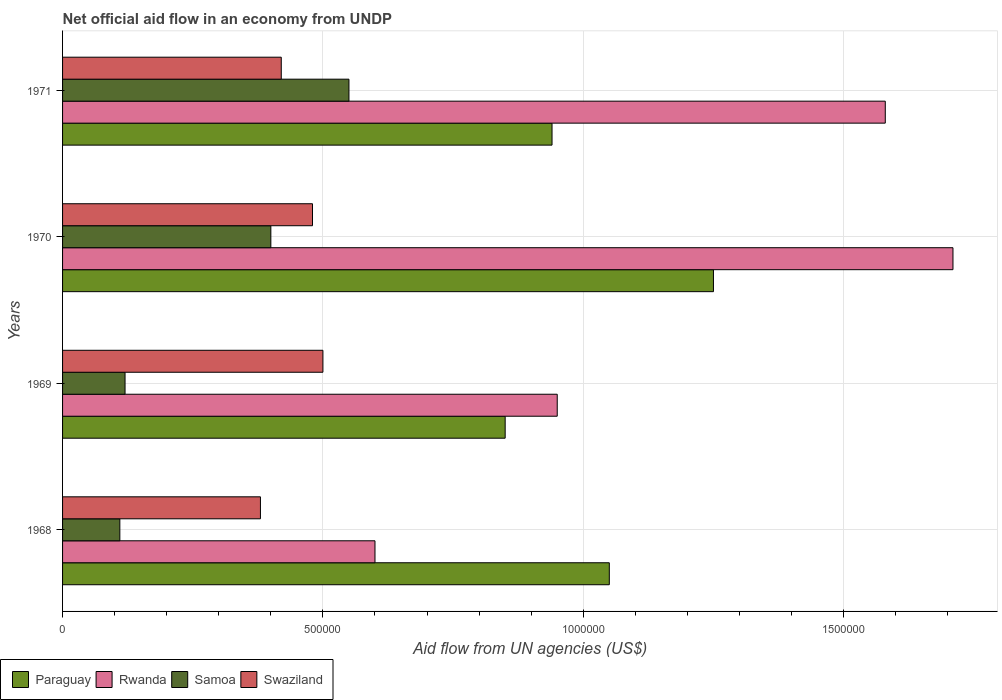Are the number of bars per tick equal to the number of legend labels?
Give a very brief answer. Yes. Are the number of bars on each tick of the Y-axis equal?
Offer a very short reply. Yes. How many bars are there on the 2nd tick from the bottom?
Your answer should be compact. 4. What is the label of the 3rd group of bars from the top?
Provide a short and direct response. 1969. What is the net official aid flow in Paraguay in 1969?
Ensure brevity in your answer.  8.50e+05. Across all years, what is the maximum net official aid flow in Paraguay?
Your answer should be compact. 1.25e+06. Across all years, what is the minimum net official aid flow in Paraguay?
Your answer should be compact. 8.50e+05. In which year was the net official aid flow in Paraguay maximum?
Make the answer very short. 1970. In which year was the net official aid flow in Swaziland minimum?
Provide a succinct answer. 1968. What is the total net official aid flow in Swaziland in the graph?
Your response must be concise. 1.78e+06. What is the difference between the net official aid flow in Samoa in 1969 and that in 1971?
Keep it short and to the point. -4.30e+05. What is the difference between the net official aid flow in Rwanda in 1971 and the net official aid flow in Samoa in 1969?
Give a very brief answer. 1.46e+06. What is the average net official aid flow in Swaziland per year?
Make the answer very short. 4.45e+05. In the year 1971, what is the difference between the net official aid flow in Samoa and net official aid flow in Paraguay?
Provide a succinct answer. -3.90e+05. In how many years, is the net official aid flow in Swaziland greater than 500000 US$?
Your response must be concise. 0. What is the ratio of the net official aid flow in Swaziland in 1970 to that in 1971?
Your answer should be very brief. 1.14. Is the net official aid flow in Samoa in 1969 less than that in 1970?
Provide a succinct answer. Yes. What is the difference between the highest and the second highest net official aid flow in Samoa?
Your response must be concise. 1.50e+05. What is the difference between the highest and the lowest net official aid flow in Paraguay?
Your answer should be compact. 4.00e+05. Is the sum of the net official aid flow in Swaziland in 1968 and 1969 greater than the maximum net official aid flow in Rwanda across all years?
Offer a very short reply. No. What does the 1st bar from the top in 1971 represents?
Ensure brevity in your answer.  Swaziland. What does the 2nd bar from the bottom in 1970 represents?
Your answer should be compact. Rwanda. Are the values on the major ticks of X-axis written in scientific E-notation?
Make the answer very short. No. Does the graph contain any zero values?
Your response must be concise. No. How many legend labels are there?
Keep it short and to the point. 4. What is the title of the graph?
Make the answer very short. Net official aid flow in an economy from UNDP. What is the label or title of the X-axis?
Make the answer very short. Aid flow from UN agencies (US$). What is the label or title of the Y-axis?
Keep it short and to the point. Years. What is the Aid flow from UN agencies (US$) of Paraguay in 1968?
Provide a succinct answer. 1.05e+06. What is the Aid flow from UN agencies (US$) in Samoa in 1968?
Your answer should be very brief. 1.10e+05. What is the Aid flow from UN agencies (US$) in Paraguay in 1969?
Provide a short and direct response. 8.50e+05. What is the Aid flow from UN agencies (US$) of Rwanda in 1969?
Your response must be concise. 9.50e+05. What is the Aid flow from UN agencies (US$) of Samoa in 1969?
Your answer should be compact. 1.20e+05. What is the Aid flow from UN agencies (US$) in Swaziland in 1969?
Your answer should be compact. 5.00e+05. What is the Aid flow from UN agencies (US$) in Paraguay in 1970?
Your answer should be very brief. 1.25e+06. What is the Aid flow from UN agencies (US$) in Rwanda in 1970?
Your answer should be very brief. 1.71e+06. What is the Aid flow from UN agencies (US$) in Samoa in 1970?
Your answer should be compact. 4.00e+05. What is the Aid flow from UN agencies (US$) in Swaziland in 1970?
Ensure brevity in your answer.  4.80e+05. What is the Aid flow from UN agencies (US$) of Paraguay in 1971?
Your answer should be very brief. 9.40e+05. What is the Aid flow from UN agencies (US$) of Rwanda in 1971?
Your answer should be very brief. 1.58e+06. What is the Aid flow from UN agencies (US$) in Swaziland in 1971?
Your answer should be compact. 4.20e+05. Across all years, what is the maximum Aid flow from UN agencies (US$) in Paraguay?
Offer a terse response. 1.25e+06. Across all years, what is the maximum Aid flow from UN agencies (US$) in Rwanda?
Offer a terse response. 1.71e+06. Across all years, what is the maximum Aid flow from UN agencies (US$) of Samoa?
Your answer should be compact. 5.50e+05. Across all years, what is the maximum Aid flow from UN agencies (US$) in Swaziland?
Make the answer very short. 5.00e+05. Across all years, what is the minimum Aid flow from UN agencies (US$) in Paraguay?
Offer a very short reply. 8.50e+05. Across all years, what is the minimum Aid flow from UN agencies (US$) in Rwanda?
Ensure brevity in your answer.  6.00e+05. What is the total Aid flow from UN agencies (US$) in Paraguay in the graph?
Make the answer very short. 4.09e+06. What is the total Aid flow from UN agencies (US$) in Rwanda in the graph?
Your response must be concise. 4.84e+06. What is the total Aid flow from UN agencies (US$) of Samoa in the graph?
Your answer should be compact. 1.18e+06. What is the total Aid flow from UN agencies (US$) in Swaziland in the graph?
Provide a short and direct response. 1.78e+06. What is the difference between the Aid flow from UN agencies (US$) of Rwanda in 1968 and that in 1969?
Your answer should be compact. -3.50e+05. What is the difference between the Aid flow from UN agencies (US$) of Swaziland in 1968 and that in 1969?
Your answer should be very brief. -1.20e+05. What is the difference between the Aid flow from UN agencies (US$) in Rwanda in 1968 and that in 1970?
Your response must be concise. -1.11e+06. What is the difference between the Aid flow from UN agencies (US$) of Samoa in 1968 and that in 1970?
Your response must be concise. -2.90e+05. What is the difference between the Aid flow from UN agencies (US$) of Paraguay in 1968 and that in 1971?
Offer a terse response. 1.10e+05. What is the difference between the Aid flow from UN agencies (US$) of Rwanda in 1968 and that in 1971?
Keep it short and to the point. -9.80e+05. What is the difference between the Aid flow from UN agencies (US$) of Samoa in 1968 and that in 1971?
Keep it short and to the point. -4.40e+05. What is the difference between the Aid flow from UN agencies (US$) of Swaziland in 1968 and that in 1971?
Give a very brief answer. -4.00e+04. What is the difference between the Aid flow from UN agencies (US$) of Paraguay in 1969 and that in 1970?
Offer a very short reply. -4.00e+05. What is the difference between the Aid flow from UN agencies (US$) of Rwanda in 1969 and that in 1970?
Provide a succinct answer. -7.60e+05. What is the difference between the Aid flow from UN agencies (US$) of Samoa in 1969 and that in 1970?
Offer a terse response. -2.80e+05. What is the difference between the Aid flow from UN agencies (US$) of Paraguay in 1969 and that in 1971?
Provide a short and direct response. -9.00e+04. What is the difference between the Aid flow from UN agencies (US$) in Rwanda in 1969 and that in 1971?
Your response must be concise. -6.30e+05. What is the difference between the Aid flow from UN agencies (US$) of Samoa in 1969 and that in 1971?
Keep it short and to the point. -4.30e+05. What is the difference between the Aid flow from UN agencies (US$) in Swaziland in 1969 and that in 1971?
Your answer should be very brief. 8.00e+04. What is the difference between the Aid flow from UN agencies (US$) of Rwanda in 1970 and that in 1971?
Give a very brief answer. 1.30e+05. What is the difference between the Aid flow from UN agencies (US$) of Swaziland in 1970 and that in 1971?
Make the answer very short. 6.00e+04. What is the difference between the Aid flow from UN agencies (US$) in Paraguay in 1968 and the Aid flow from UN agencies (US$) in Rwanda in 1969?
Ensure brevity in your answer.  1.00e+05. What is the difference between the Aid flow from UN agencies (US$) of Paraguay in 1968 and the Aid flow from UN agencies (US$) of Samoa in 1969?
Keep it short and to the point. 9.30e+05. What is the difference between the Aid flow from UN agencies (US$) of Samoa in 1968 and the Aid flow from UN agencies (US$) of Swaziland in 1969?
Ensure brevity in your answer.  -3.90e+05. What is the difference between the Aid flow from UN agencies (US$) in Paraguay in 1968 and the Aid flow from UN agencies (US$) in Rwanda in 1970?
Provide a short and direct response. -6.60e+05. What is the difference between the Aid flow from UN agencies (US$) of Paraguay in 1968 and the Aid flow from UN agencies (US$) of Samoa in 1970?
Ensure brevity in your answer.  6.50e+05. What is the difference between the Aid flow from UN agencies (US$) of Paraguay in 1968 and the Aid flow from UN agencies (US$) of Swaziland in 1970?
Provide a succinct answer. 5.70e+05. What is the difference between the Aid flow from UN agencies (US$) of Rwanda in 1968 and the Aid flow from UN agencies (US$) of Swaziland in 1970?
Make the answer very short. 1.20e+05. What is the difference between the Aid flow from UN agencies (US$) in Samoa in 1968 and the Aid flow from UN agencies (US$) in Swaziland in 1970?
Keep it short and to the point. -3.70e+05. What is the difference between the Aid flow from UN agencies (US$) in Paraguay in 1968 and the Aid flow from UN agencies (US$) in Rwanda in 1971?
Offer a terse response. -5.30e+05. What is the difference between the Aid flow from UN agencies (US$) in Paraguay in 1968 and the Aid flow from UN agencies (US$) in Swaziland in 1971?
Offer a terse response. 6.30e+05. What is the difference between the Aid flow from UN agencies (US$) of Rwanda in 1968 and the Aid flow from UN agencies (US$) of Samoa in 1971?
Make the answer very short. 5.00e+04. What is the difference between the Aid flow from UN agencies (US$) of Samoa in 1968 and the Aid flow from UN agencies (US$) of Swaziland in 1971?
Your answer should be very brief. -3.10e+05. What is the difference between the Aid flow from UN agencies (US$) in Paraguay in 1969 and the Aid flow from UN agencies (US$) in Rwanda in 1970?
Provide a succinct answer. -8.60e+05. What is the difference between the Aid flow from UN agencies (US$) of Paraguay in 1969 and the Aid flow from UN agencies (US$) of Swaziland in 1970?
Keep it short and to the point. 3.70e+05. What is the difference between the Aid flow from UN agencies (US$) of Samoa in 1969 and the Aid flow from UN agencies (US$) of Swaziland in 1970?
Offer a terse response. -3.60e+05. What is the difference between the Aid flow from UN agencies (US$) in Paraguay in 1969 and the Aid flow from UN agencies (US$) in Rwanda in 1971?
Make the answer very short. -7.30e+05. What is the difference between the Aid flow from UN agencies (US$) in Paraguay in 1969 and the Aid flow from UN agencies (US$) in Swaziland in 1971?
Your answer should be compact. 4.30e+05. What is the difference between the Aid flow from UN agencies (US$) of Rwanda in 1969 and the Aid flow from UN agencies (US$) of Swaziland in 1971?
Your answer should be very brief. 5.30e+05. What is the difference between the Aid flow from UN agencies (US$) in Samoa in 1969 and the Aid flow from UN agencies (US$) in Swaziland in 1971?
Your response must be concise. -3.00e+05. What is the difference between the Aid flow from UN agencies (US$) in Paraguay in 1970 and the Aid flow from UN agencies (US$) in Rwanda in 1971?
Your answer should be very brief. -3.30e+05. What is the difference between the Aid flow from UN agencies (US$) in Paraguay in 1970 and the Aid flow from UN agencies (US$) in Samoa in 1971?
Your response must be concise. 7.00e+05. What is the difference between the Aid flow from UN agencies (US$) of Paraguay in 1970 and the Aid flow from UN agencies (US$) of Swaziland in 1971?
Give a very brief answer. 8.30e+05. What is the difference between the Aid flow from UN agencies (US$) in Rwanda in 1970 and the Aid flow from UN agencies (US$) in Samoa in 1971?
Offer a terse response. 1.16e+06. What is the difference between the Aid flow from UN agencies (US$) in Rwanda in 1970 and the Aid flow from UN agencies (US$) in Swaziland in 1971?
Provide a short and direct response. 1.29e+06. What is the difference between the Aid flow from UN agencies (US$) of Samoa in 1970 and the Aid flow from UN agencies (US$) of Swaziland in 1971?
Your answer should be very brief. -2.00e+04. What is the average Aid flow from UN agencies (US$) of Paraguay per year?
Provide a succinct answer. 1.02e+06. What is the average Aid flow from UN agencies (US$) in Rwanda per year?
Make the answer very short. 1.21e+06. What is the average Aid flow from UN agencies (US$) in Samoa per year?
Ensure brevity in your answer.  2.95e+05. What is the average Aid flow from UN agencies (US$) in Swaziland per year?
Keep it short and to the point. 4.45e+05. In the year 1968, what is the difference between the Aid flow from UN agencies (US$) in Paraguay and Aid flow from UN agencies (US$) in Rwanda?
Your response must be concise. 4.50e+05. In the year 1968, what is the difference between the Aid flow from UN agencies (US$) of Paraguay and Aid flow from UN agencies (US$) of Samoa?
Offer a very short reply. 9.40e+05. In the year 1968, what is the difference between the Aid flow from UN agencies (US$) of Paraguay and Aid flow from UN agencies (US$) of Swaziland?
Provide a succinct answer. 6.70e+05. In the year 1968, what is the difference between the Aid flow from UN agencies (US$) in Rwanda and Aid flow from UN agencies (US$) in Samoa?
Your answer should be compact. 4.90e+05. In the year 1968, what is the difference between the Aid flow from UN agencies (US$) of Rwanda and Aid flow from UN agencies (US$) of Swaziland?
Provide a succinct answer. 2.20e+05. In the year 1969, what is the difference between the Aid flow from UN agencies (US$) of Paraguay and Aid flow from UN agencies (US$) of Samoa?
Provide a succinct answer. 7.30e+05. In the year 1969, what is the difference between the Aid flow from UN agencies (US$) of Paraguay and Aid flow from UN agencies (US$) of Swaziland?
Ensure brevity in your answer.  3.50e+05. In the year 1969, what is the difference between the Aid flow from UN agencies (US$) of Rwanda and Aid flow from UN agencies (US$) of Samoa?
Keep it short and to the point. 8.30e+05. In the year 1969, what is the difference between the Aid flow from UN agencies (US$) in Samoa and Aid flow from UN agencies (US$) in Swaziland?
Your response must be concise. -3.80e+05. In the year 1970, what is the difference between the Aid flow from UN agencies (US$) in Paraguay and Aid flow from UN agencies (US$) in Rwanda?
Keep it short and to the point. -4.60e+05. In the year 1970, what is the difference between the Aid flow from UN agencies (US$) of Paraguay and Aid flow from UN agencies (US$) of Samoa?
Your answer should be very brief. 8.50e+05. In the year 1970, what is the difference between the Aid flow from UN agencies (US$) in Paraguay and Aid flow from UN agencies (US$) in Swaziland?
Offer a very short reply. 7.70e+05. In the year 1970, what is the difference between the Aid flow from UN agencies (US$) in Rwanda and Aid flow from UN agencies (US$) in Samoa?
Offer a terse response. 1.31e+06. In the year 1970, what is the difference between the Aid flow from UN agencies (US$) in Rwanda and Aid flow from UN agencies (US$) in Swaziland?
Your answer should be compact. 1.23e+06. In the year 1971, what is the difference between the Aid flow from UN agencies (US$) in Paraguay and Aid flow from UN agencies (US$) in Rwanda?
Provide a succinct answer. -6.40e+05. In the year 1971, what is the difference between the Aid flow from UN agencies (US$) in Paraguay and Aid flow from UN agencies (US$) in Swaziland?
Your response must be concise. 5.20e+05. In the year 1971, what is the difference between the Aid flow from UN agencies (US$) in Rwanda and Aid flow from UN agencies (US$) in Samoa?
Provide a short and direct response. 1.03e+06. In the year 1971, what is the difference between the Aid flow from UN agencies (US$) of Rwanda and Aid flow from UN agencies (US$) of Swaziland?
Offer a very short reply. 1.16e+06. What is the ratio of the Aid flow from UN agencies (US$) in Paraguay in 1968 to that in 1969?
Keep it short and to the point. 1.24. What is the ratio of the Aid flow from UN agencies (US$) in Rwanda in 1968 to that in 1969?
Your answer should be compact. 0.63. What is the ratio of the Aid flow from UN agencies (US$) of Swaziland in 1968 to that in 1969?
Your response must be concise. 0.76. What is the ratio of the Aid flow from UN agencies (US$) of Paraguay in 1968 to that in 1970?
Provide a succinct answer. 0.84. What is the ratio of the Aid flow from UN agencies (US$) in Rwanda in 1968 to that in 1970?
Keep it short and to the point. 0.35. What is the ratio of the Aid flow from UN agencies (US$) in Samoa in 1968 to that in 1970?
Offer a very short reply. 0.28. What is the ratio of the Aid flow from UN agencies (US$) of Swaziland in 1968 to that in 1970?
Provide a short and direct response. 0.79. What is the ratio of the Aid flow from UN agencies (US$) in Paraguay in 1968 to that in 1971?
Your response must be concise. 1.12. What is the ratio of the Aid flow from UN agencies (US$) in Rwanda in 1968 to that in 1971?
Offer a terse response. 0.38. What is the ratio of the Aid flow from UN agencies (US$) of Swaziland in 1968 to that in 1971?
Ensure brevity in your answer.  0.9. What is the ratio of the Aid flow from UN agencies (US$) in Paraguay in 1969 to that in 1970?
Make the answer very short. 0.68. What is the ratio of the Aid flow from UN agencies (US$) of Rwanda in 1969 to that in 1970?
Provide a short and direct response. 0.56. What is the ratio of the Aid flow from UN agencies (US$) in Swaziland in 1969 to that in 1970?
Give a very brief answer. 1.04. What is the ratio of the Aid flow from UN agencies (US$) in Paraguay in 1969 to that in 1971?
Your response must be concise. 0.9. What is the ratio of the Aid flow from UN agencies (US$) in Rwanda in 1969 to that in 1971?
Your response must be concise. 0.6. What is the ratio of the Aid flow from UN agencies (US$) in Samoa in 1969 to that in 1971?
Give a very brief answer. 0.22. What is the ratio of the Aid flow from UN agencies (US$) of Swaziland in 1969 to that in 1971?
Ensure brevity in your answer.  1.19. What is the ratio of the Aid flow from UN agencies (US$) of Paraguay in 1970 to that in 1971?
Give a very brief answer. 1.33. What is the ratio of the Aid flow from UN agencies (US$) of Rwanda in 1970 to that in 1971?
Ensure brevity in your answer.  1.08. What is the ratio of the Aid flow from UN agencies (US$) in Samoa in 1970 to that in 1971?
Offer a terse response. 0.73. What is the ratio of the Aid flow from UN agencies (US$) in Swaziland in 1970 to that in 1971?
Give a very brief answer. 1.14. What is the difference between the highest and the second highest Aid flow from UN agencies (US$) in Rwanda?
Give a very brief answer. 1.30e+05. What is the difference between the highest and the lowest Aid flow from UN agencies (US$) of Rwanda?
Give a very brief answer. 1.11e+06. 